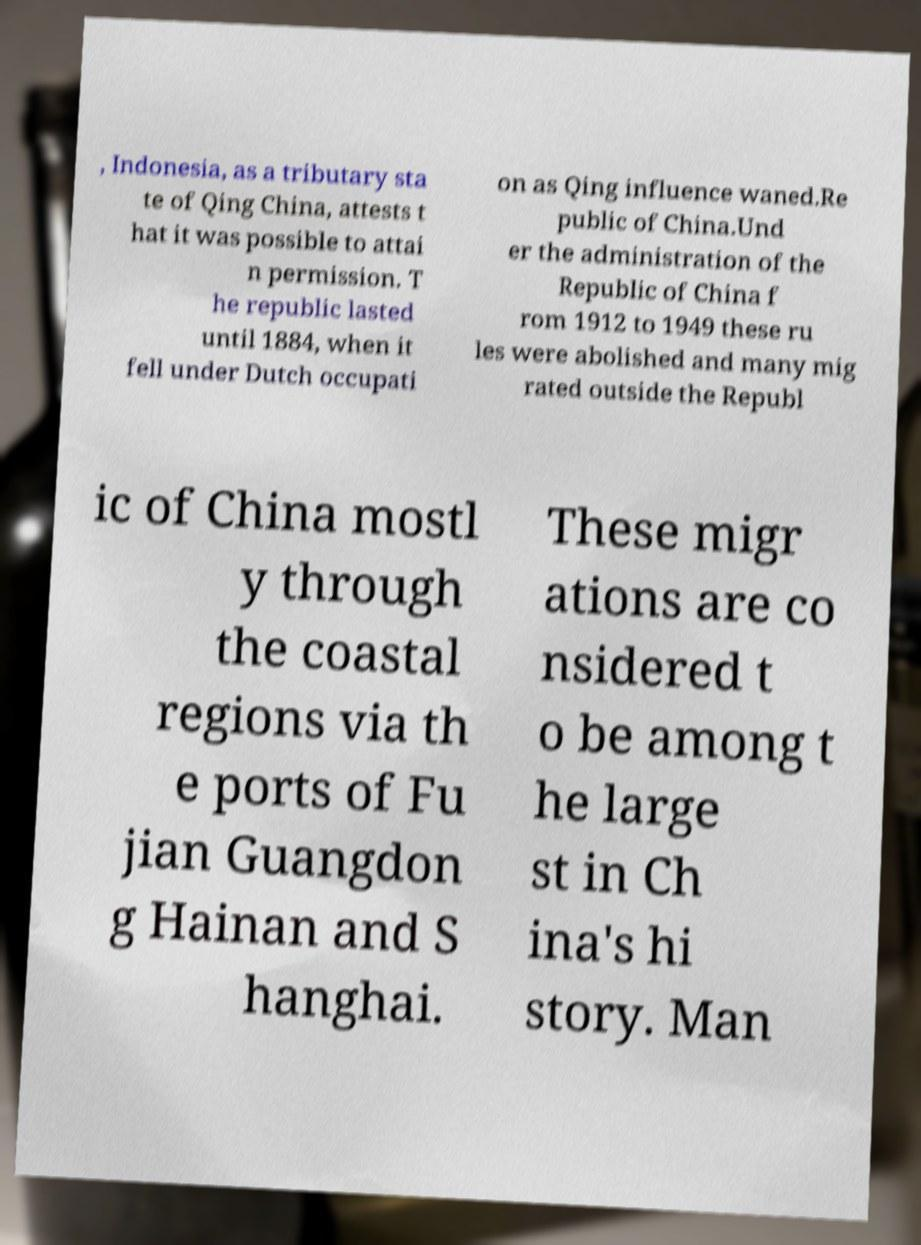Could you assist in decoding the text presented in this image and type it out clearly? , Indonesia, as a tributary sta te of Qing China, attests t hat it was possible to attai n permission. T he republic lasted until 1884, when it fell under Dutch occupati on as Qing influence waned.Re public of China.Und er the administration of the Republic of China f rom 1912 to 1949 these ru les were abolished and many mig rated outside the Republ ic of China mostl y through the coastal regions via th e ports of Fu jian Guangdon g Hainan and S hanghai. These migr ations are co nsidered t o be among t he large st in Ch ina's hi story. Man 